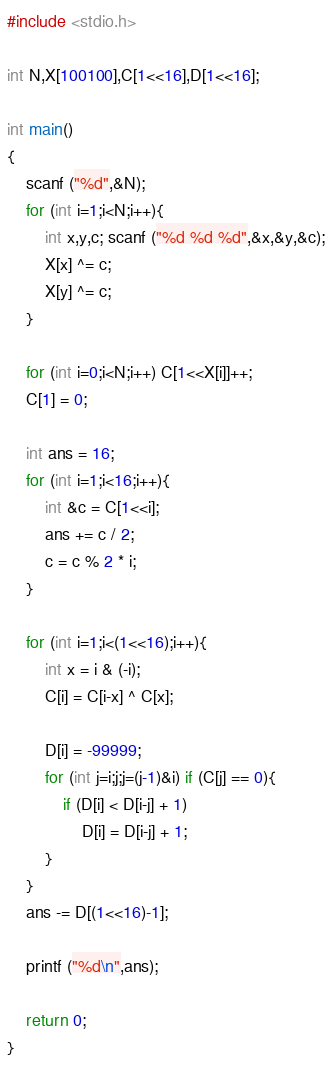<code> <loc_0><loc_0><loc_500><loc_500><_C++_>#include <stdio.h>

int N,X[100100],C[1<<16],D[1<<16];

int main()
{
	scanf ("%d",&N);
	for (int i=1;i<N;i++){
		int x,y,c; scanf ("%d %d %d",&x,&y,&c);
		X[x] ^= c;
		X[y] ^= c;
	}

	for (int i=0;i<N;i++) C[1<<X[i]]++;
	C[1] = 0;

	int ans = 16;
	for (int i=1;i<16;i++){
		int &c = C[1<<i];
		ans += c / 2;
		c = c % 2 * i;
	}

	for (int i=1;i<(1<<16);i++){
		int x = i & (-i);
		C[i] = C[i-x] ^ C[x];

		D[i] = -99999;
		for (int j=i;j;j=(j-1)&i) if (C[j] == 0){
			if (D[i] < D[i-j] + 1)
				D[i] = D[i-j] + 1;
		}
	}
	ans -= D[(1<<16)-1];

	printf ("%d\n",ans);

	return 0;
}</code> 